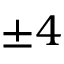<formula> <loc_0><loc_0><loc_500><loc_500>\pm 4</formula> 